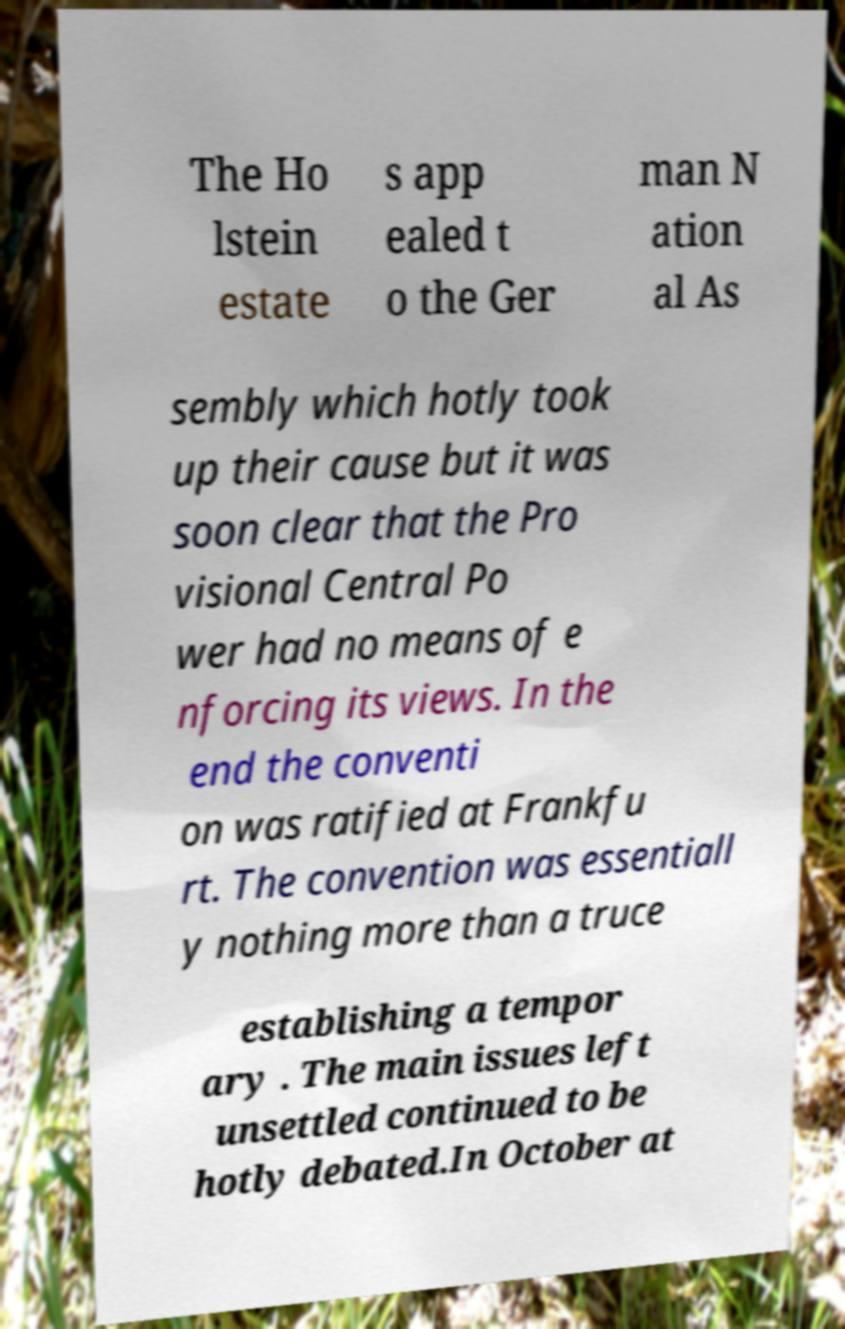Please read and relay the text visible in this image. What does it say? The Ho lstein estate s app ealed t o the Ger man N ation al As sembly which hotly took up their cause but it was soon clear that the Pro visional Central Po wer had no means of e nforcing its views. In the end the conventi on was ratified at Frankfu rt. The convention was essentiall y nothing more than a truce establishing a tempor ary . The main issues left unsettled continued to be hotly debated.In October at 